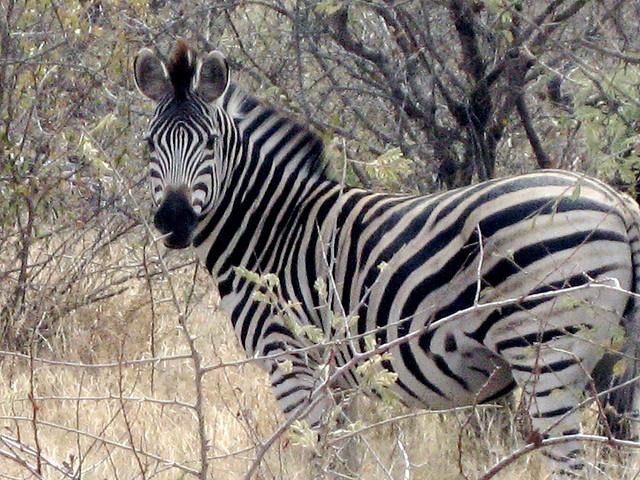What animal is this?
Write a very short answer. Zebra. What is surrounding the zebra?
Short answer required. Trees. What color is the grass?
Quick response, please. Brown. How many animals are pictured?
Write a very short answer. 1. 